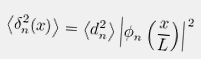Convert formula to latex. <formula><loc_0><loc_0><loc_500><loc_500>\left \langle \delta _ { n } ^ { 2 } ( x ) \right \rangle = \left \langle d _ { n } ^ { 2 } \right \rangle \left | \phi _ { n } \left ( \frac { x } { L } \right ) \right | ^ { 2 }</formula> 